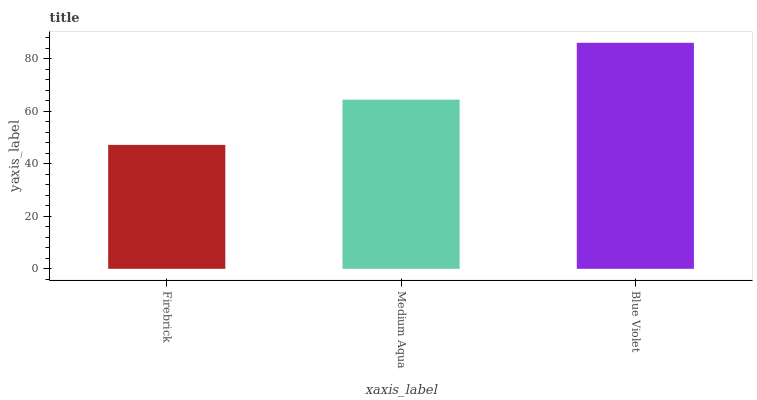Is Blue Violet the maximum?
Answer yes or no. Yes. Is Medium Aqua the minimum?
Answer yes or no. No. Is Medium Aqua the maximum?
Answer yes or no. No. Is Medium Aqua greater than Firebrick?
Answer yes or no. Yes. Is Firebrick less than Medium Aqua?
Answer yes or no. Yes. Is Firebrick greater than Medium Aqua?
Answer yes or no. No. Is Medium Aqua less than Firebrick?
Answer yes or no. No. Is Medium Aqua the high median?
Answer yes or no. Yes. Is Medium Aqua the low median?
Answer yes or no. Yes. Is Blue Violet the high median?
Answer yes or no. No. Is Blue Violet the low median?
Answer yes or no. No. 